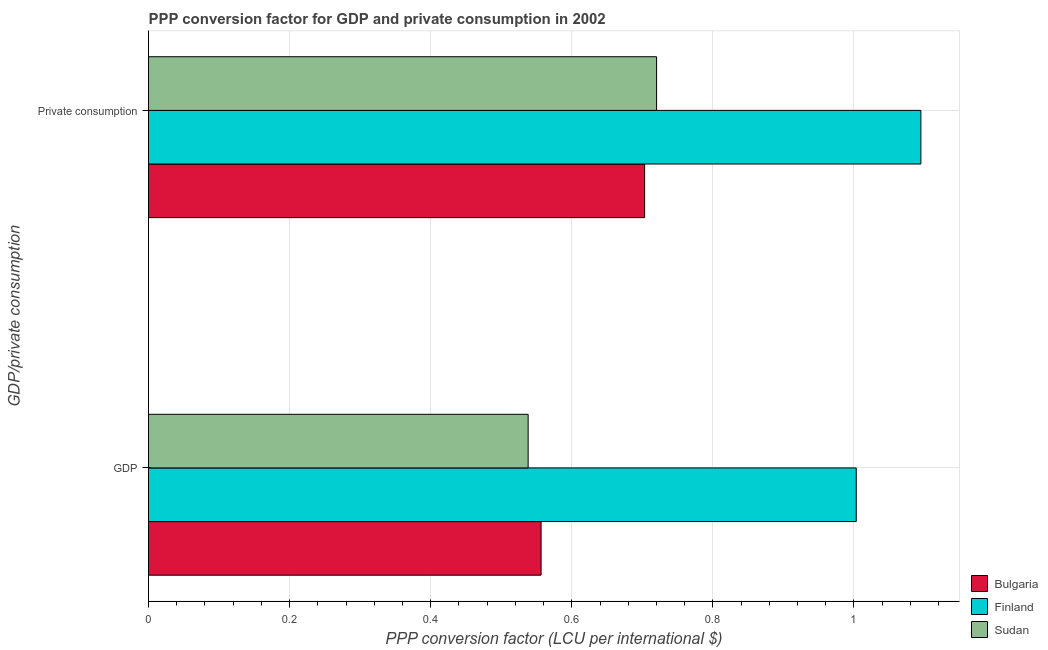How many groups of bars are there?
Your response must be concise. 2. Are the number of bars per tick equal to the number of legend labels?
Your response must be concise. Yes. How many bars are there on the 2nd tick from the top?
Keep it short and to the point. 3. What is the label of the 1st group of bars from the top?
Offer a terse response.  Private consumption. What is the ppp conversion factor for private consumption in Finland?
Give a very brief answer. 1.09. Across all countries, what is the maximum ppp conversion factor for private consumption?
Provide a succinct answer. 1.09. Across all countries, what is the minimum ppp conversion factor for private consumption?
Provide a succinct answer. 0.7. In which country was the ppp conversion factor for gdp minimum?
Your response must be concise. Sudan. What is the total ppp conversion factor for gdp in the graph?
Provide a short and direct response. 2.1. What is the difference between the ppp conversion factor for private consumption in Finland and that in Bulgaria?
Give a very brief answer. 0.39. What is the difference between the ppp conversion factor for gdp in Sudan and the ppp conversion factor for private consumption in Bulgaria?
Offer a very short reply. -0.17. What is the average ppp conversion factor for private consumption per country?
Provide a short and direct response. 0.84. What is the difference between the ppp conversion factor for gdp and ppp conversion factor for private consumption in Sudan?
Provide a short and direct response. -0.18. In how many countries, is the ppp conversion factor for private consumption greater than 0.8 LCU?
Your answer should be very brief. 1. What is the ratio of the ppp conversion factor for gdp in Bulgaria to that in Sudan?
Your response must be concise. 1.03. Is the ppp conversion factor for private consumption in Finland less than that in Bulgaria?
Offer a terse response. No. In how many countries, is the ppp conversion factor for private consumption greater than the average ppp conversion factor for private consumption taken over all countries?
Ensure brevity in your answer.  1. What does the 1st bar from the bottom in GDP represents?
Make the answer very short. Bulgaria. How many countries are there in the graph?
Provide a succinct answer. 3. Does the graph contain grids?
Give a very brief answer. Yes. Where does the legend appear in the graph?
Your response must be concise. Bottom right. How many legend labels are there?
Offer a very short reply. 3. How are the legend labels stacked?
Make the answer very short. Vertical. What is the title of the graph?
Your answer should be compact. PPP conversion factor for GDP and private consumption in 2002. What is the label or title of the X-axis?
Your answer should be very brief. PPP conversion factor (LCU per international $). What is the label or title of the Y-axis?
Give a very brief answer. GDP/private consumption. What is the PPP conversion factor (LCU per international $) in Bulgaria in GDP?
Offer a terse response. 0.56. What is the PPP conversion factor (LCU per international $) of Finland in GDP?
Provide a short and direct response. 1. What is the PPP conversion factor (LCU per international $) in Sudan in GDP?
Your answer should be compact. 0.54. What is the PPP conversion factor (LCU per international $) in Bulgaria in  Private consumption?
Your answer should be very brief. 0.7. What is the PPP conversion factor (LCU per international $) in Finland in  Private consumption?
Offer a terse response. 1.09. What is the PPP conversion factor (LCU per international $) in Sudan in  Private consumption?
Provide a succinct answer. 0.72. Across all GDP/private consumption, what is the maximum PPP conversion factor (LCU per international $) of Bulgaria?
Offer a terse response. 0.7. Across all GDP/private consumption, what is the maximum PPP conversion factor (LCU per international $) of Finland?
Offer a terse response. 1.09. Across all GDP/private consumption, what is the maximum PPP conversion factor (LCU per international $) of Sudan?
Offer a terse response. 0.72. Across all GDP/private consumption, what is the minimum PPP conversion factor (LCU per international $) in Bulgaria?
Provide a succinct answer. 0.56. Across all GDP/private consumption, what is the minimum PPP conversion factor (LCU per international $) in Finland?
Keep it short and to the point. 1. Across all GDP/private consumption, what is the minimum PPP conversion factor (LCU per international $) in Sudan?
Provide a succinct answer. 0.54. What is the total PPP conversion factor (LCU per international $) of Bulgaria in the graph?
Ensure brevity in your answer.  1.26. What is the total PPP conversion factor (LCU per international $) of Finland in the graph?
Provide a succinct answer. 2.1. What is the total PPP conversion factor (LCU per international $) in Sudan in the graph?
Your answer should be compact. 1.26. What is the difference between the PPP conversion factor (LCU per international $) of Bulgaria in GDP and that in  Private consumption?
Your answer should be very brief. -0.15. What is the difference between the PPP conversion factor (LCU per international $) of Finland in GDP and that in  Private consumption?
Offer a very short reply. -0.09. What is the difference between the PPP conversion factor (LCU per international $) of Sudan in GDP and that in  Private consumption?
Provide a short and direct response. -0.18. What is the difference between the PPP conversion factor (LCU per international $) in Bulgaria in GDP and the PPP conversion factor (LCU per international $) in Finland in  Private consumption?
Provide a succinct answer. -0.54. What is the difference between the PPP conversion factor (LCU per international $) of Bulgaria in GDP and the PPP conversion factor (LCU per international $) of Sudan in  Private consumption?
Ensure brevity in your answer.  -0.16. What is the difference between the PPP conversion factor (LCU per international $) in Finland in GDP and the PPP conversion factor (LCU per international $) in Sudan in  Private consumption?
Provide a succinct answer. 0.28. What is the average PPP conversion factor (LCU per international $) of Bulgaria per GDP/private consumption?
Offer a terse response. 0.63. What is the average PPP conversion factor (LCU per international $) in Finland per GDP/private consumption?
Provide a succinct answer. 1.05. What is the average PPP conversion factor (LCU per international $) of Sudan per GDP/private consumption?
Make the answer very short. 0.63. What is the difference between the PPP conversion factor (LCU per international $) in Bulgaria and PPP conversion factor (LCU per international $) in Finland in GDP?
Offer a terse response. -0.45. What is the difference between the PPP conversion factor (LCU per international $) of Bulgaria and PPP conversion factor (LCU per international $) of Sudan in GDP?
Provide a short and direct response. 0.02. What is the difference between the PPP conversion factor (LCU per international $) in Finland and PPP conversion factor (LCU per international $) in Sudan in GDP?
Your answer should be compact. 0.47. What is the difference between the PPP conversion factor (LCU per international $) in Bulgaria and PPP conversion factor (LCU per international $) in Finland in  Private consumption?
Make the answer very short. -0.39. What is the difference between the PPP conversion factor (LCU per international $) of Bulgaria and PPP conversion factor (LCU per international $) of Sudan in  Private consumption?
Provide a short and direct response. -0.02. What is the difference between the PPP conversion factor (LCU per international $) of Finland and PPP conversion factor (LCU per international $) of Sudan in  Private consumption?
Make the answer very short. 0.37. What is the ratio of the PPP conversion factor (LCU per international $) in Bulgaria in GDP to that in  Private consumption?
Provide a short and direct response. 0.79. What is the ratio of the PPP conversion factor (LCU per international $) of Finland in GDP to that in  Private consumption?
Give a very brief answer. 0.92. What is the ratio of the PPP conversion factor (LCU per international $) of Sudan in GDP to that in  Private consumption?
Offer a terse response. 0.75. What is the difference between the highest and the second highest PPP conversion factor (LCU per international $) of Bulgaria?
Make the answer very short. 0.15. What is the difference between the highest and the second highest PPP conversion factor (LCU per international $) of Finland?
Offer a very short reply. 0.09. What is the difference between the highest and the second highest PPP conversion factor (LCU per international $) in Sudan?
Your answer should be very brief. 0.18. What is the difference between the highest and the lowest PPP conversion factor (LCU per international $) of Bulgaria?
Provide a succinct answer. 0.15. What is the difference between the highest and the lowest PPP conversion factor (LCU per international $) of Finland?
Keep it short and to the point. 0.09. What is the difference between the highest and the lowest PPP conversion factor (LCU per international $) of Sudan?
Your answer should be very brief. 0.18. 